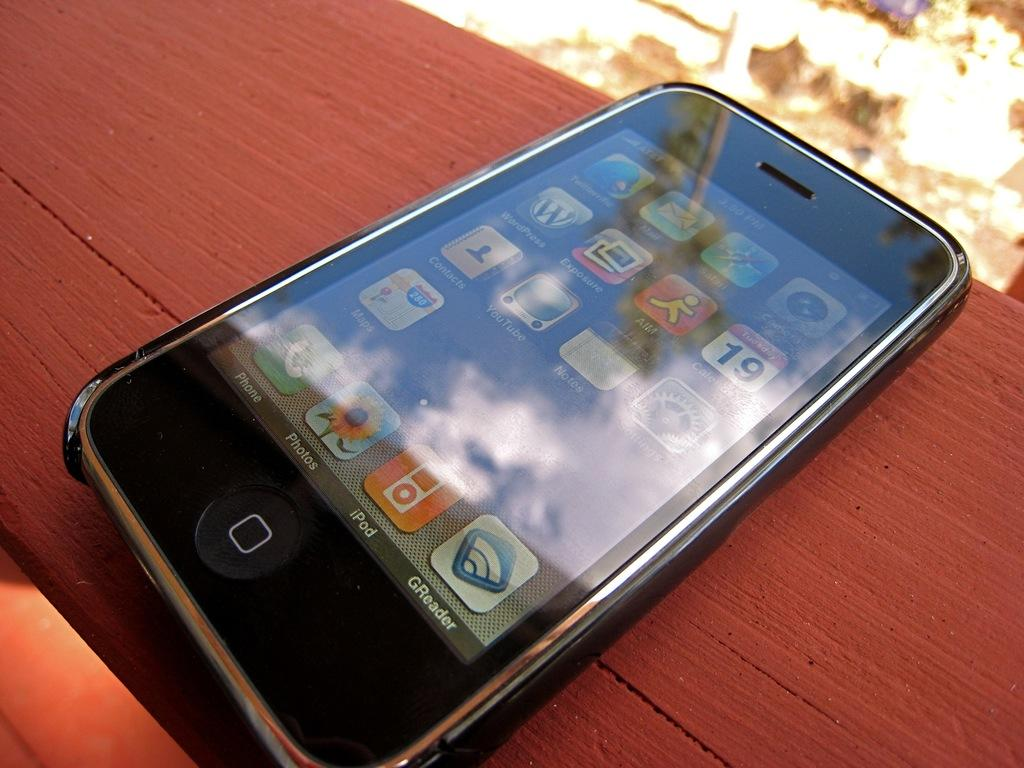<image>
Describe the image concisely. An Iphone sitting on a wood panel of a desk 